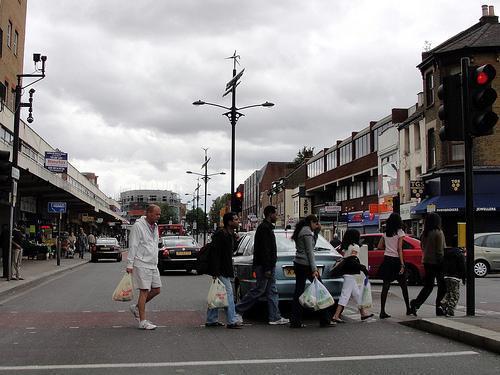How many bags are there?
Give a very brief answer. 4. How many people crossing the street have grocery bags?
Give a very brief answer. 4. 